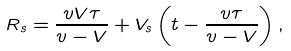<formula> <loc_0><loc_0><loc_500><loc_500>R _ { s } = \frac { v V \tau } { v - V } + V _ { s } \left ( t - \frac { v \tau } { v - V } \right ) ,</formula> 